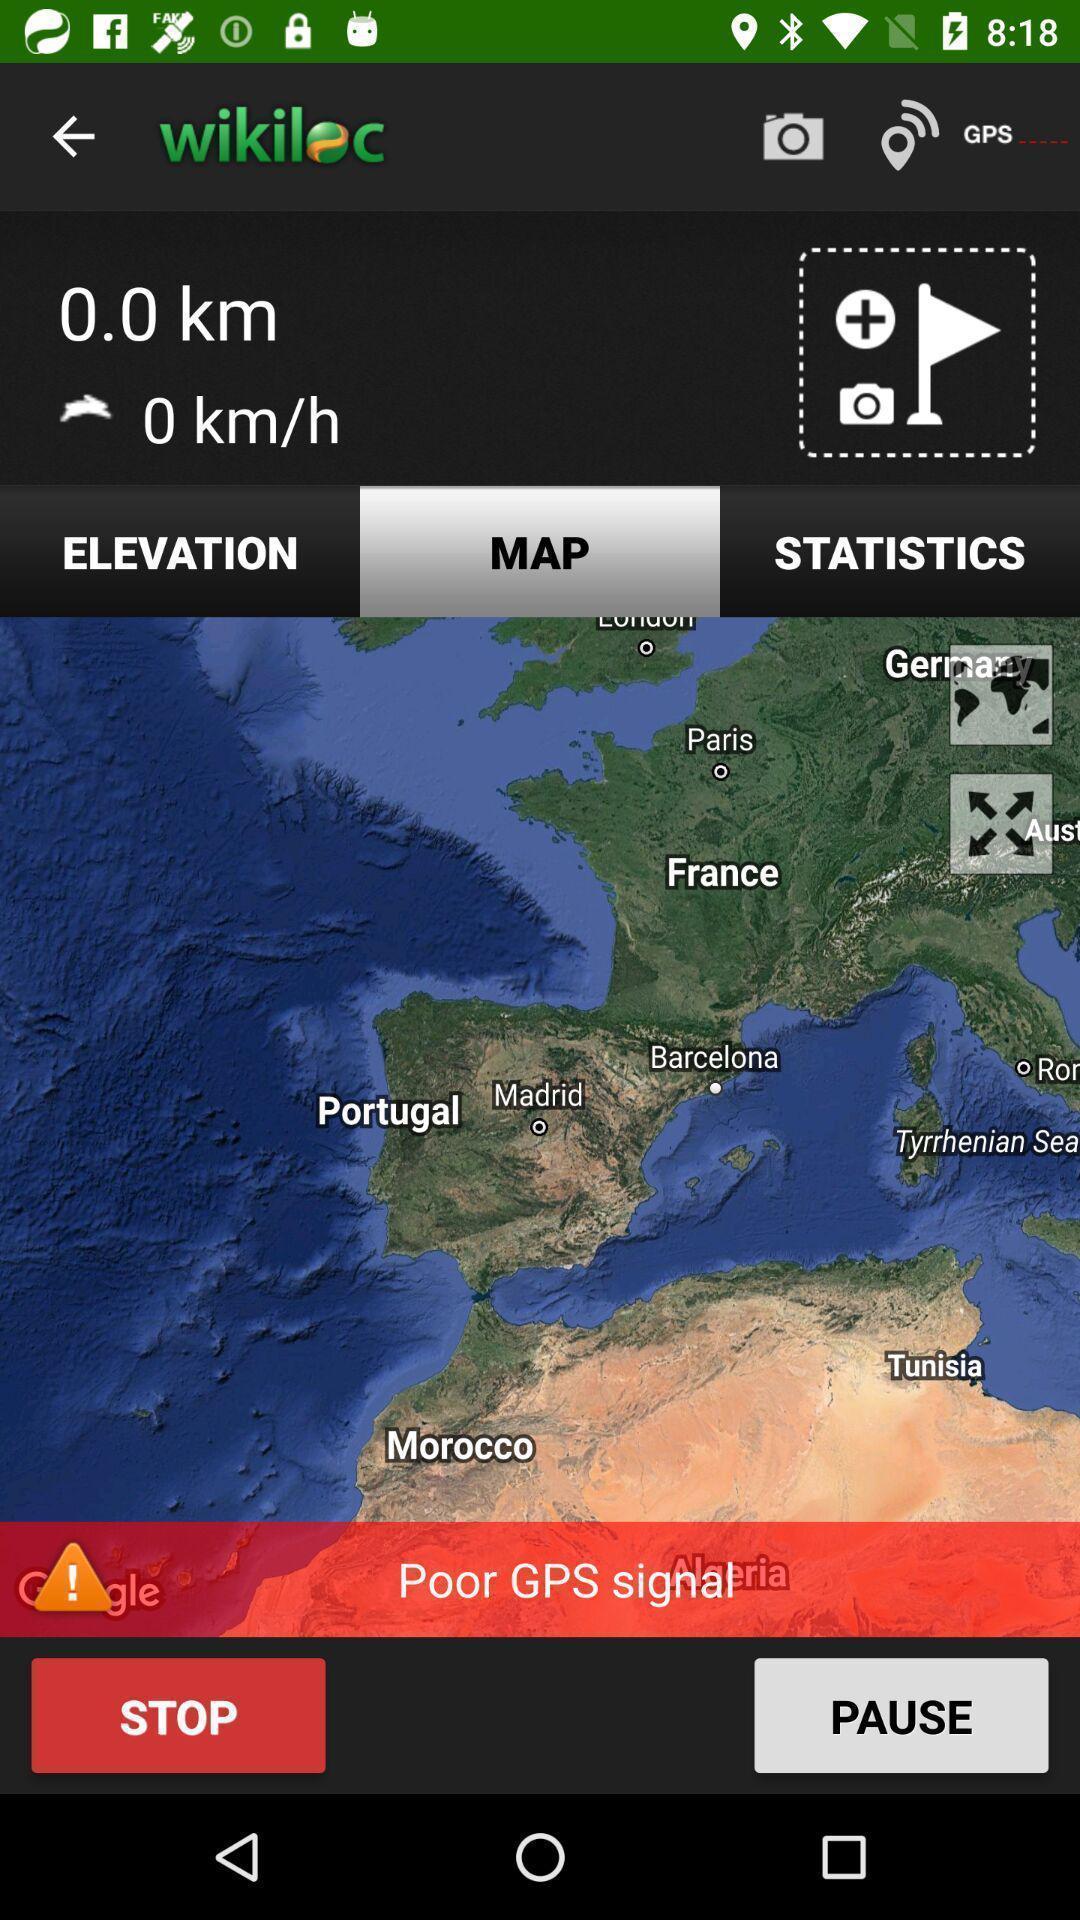Describe the content in this image. Page displaying with maps and with few options. 